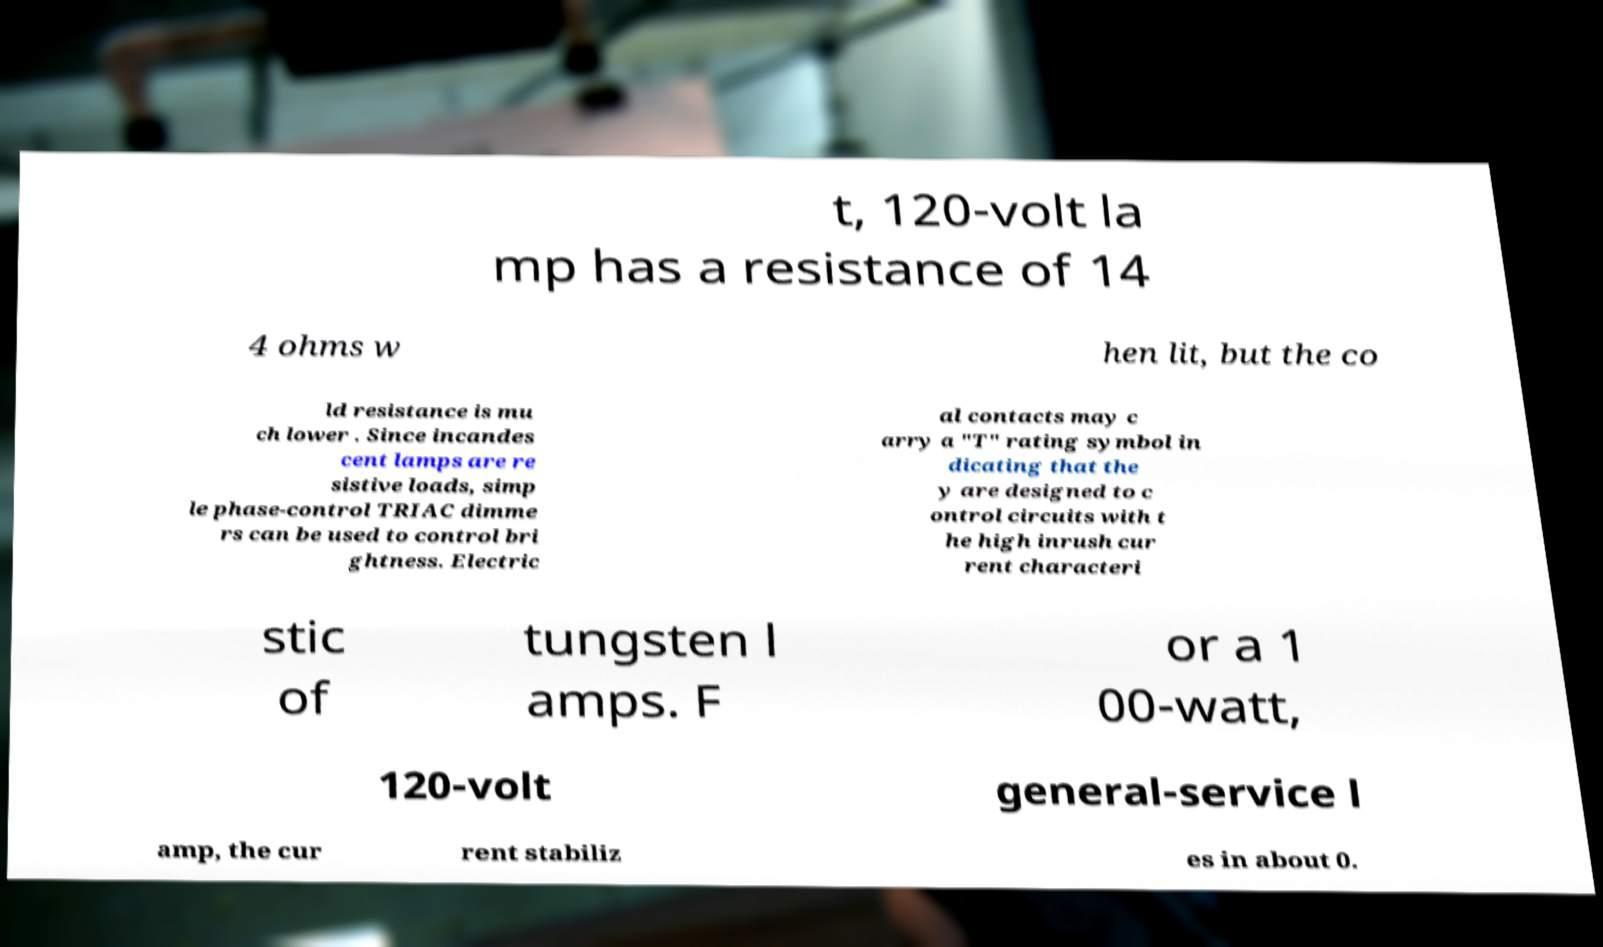Can you accurately transcribe the text from the provided image for me? t, 120-volt la mp has a resistance of 14 4 ohms w hen lit, but the co ld resistance is mu ch lower . Since incandes cent lamps are re sistive loads, simp le phase-control TRIAC dimme rs can be used to control bri ghtness. Electric al contacts may c arry a "T" rating symbol in dicating that the y are designed to c ontrol circuits with t he high inrush cur rent characteri stic of tungsten l amps. F or a 1 00-watt, 120-volt general-service l amp, the cur rent stabiliz es in about 0. 